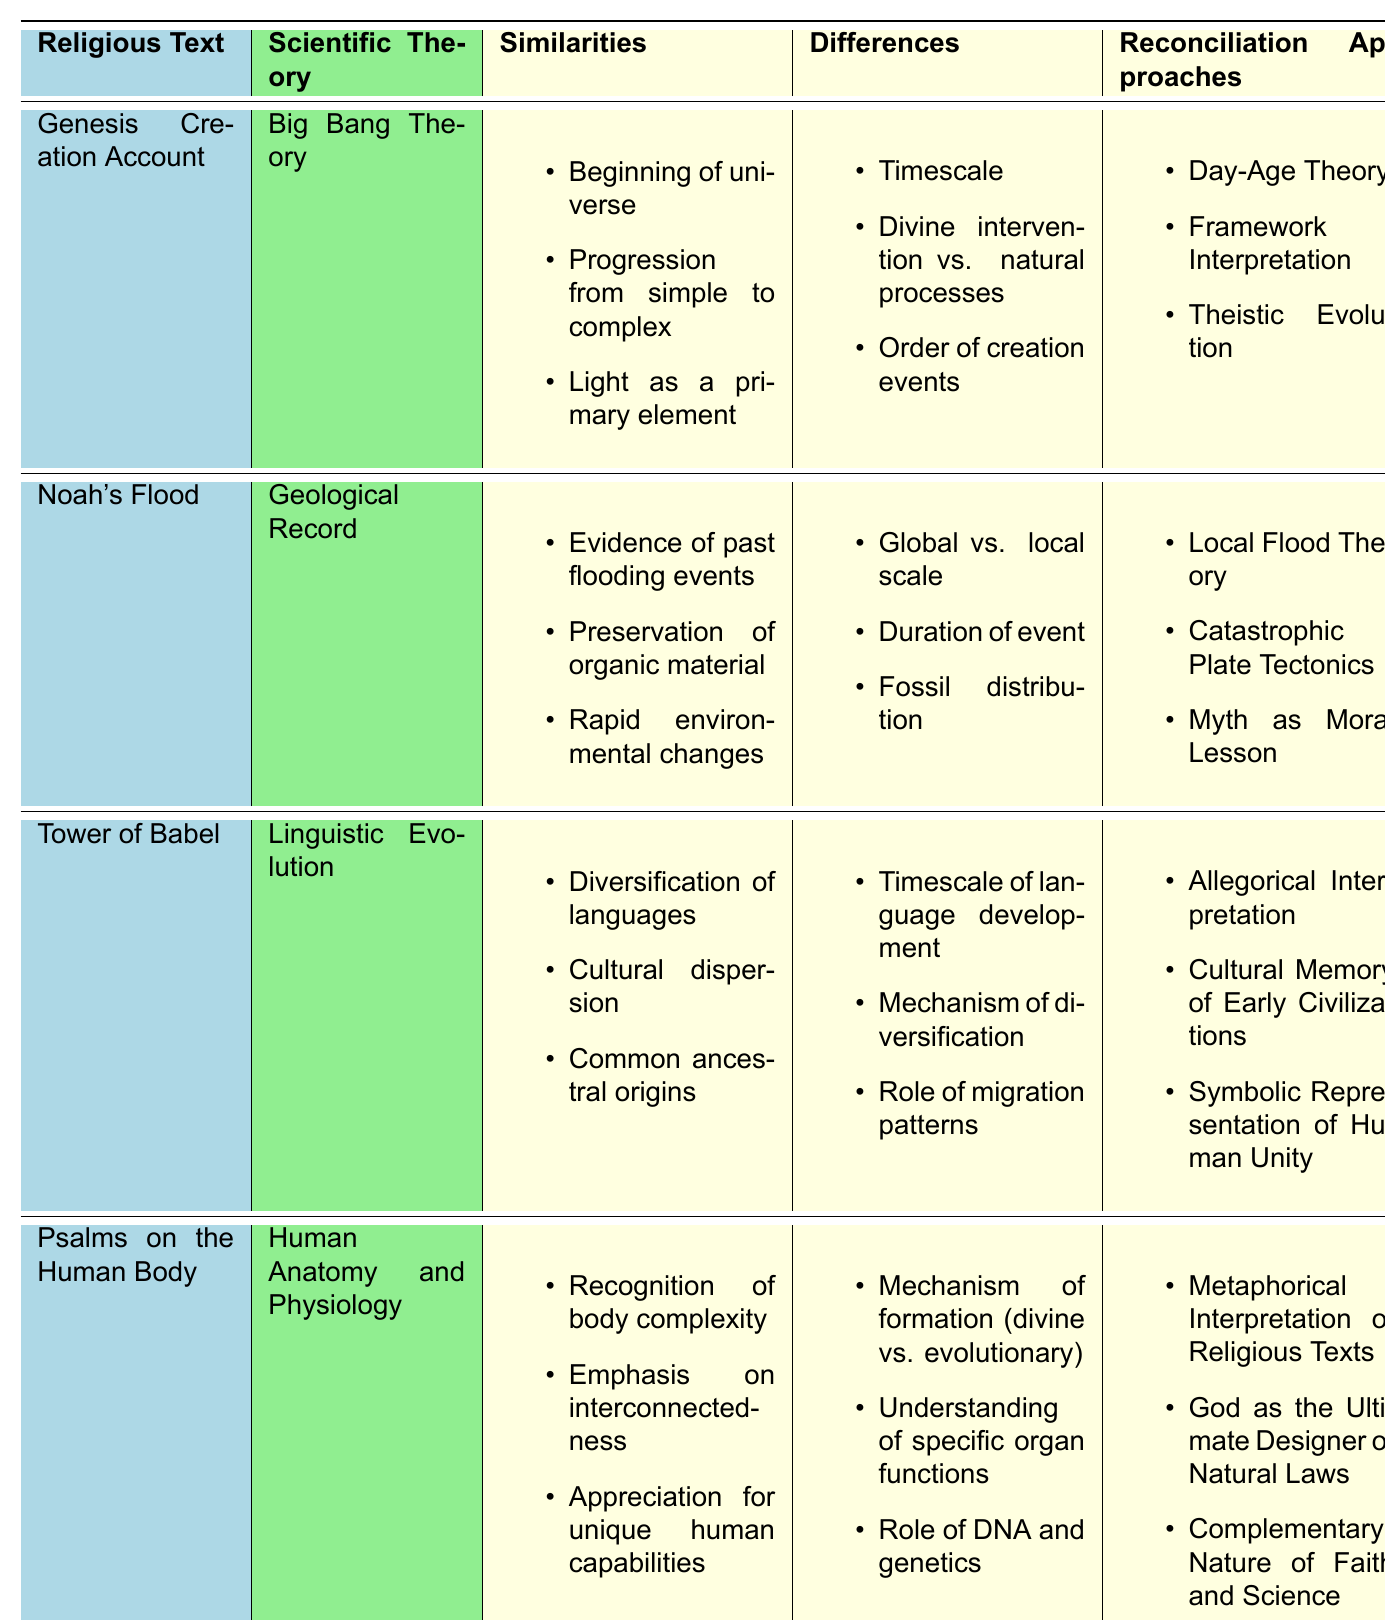What religious text corresponds with the Big Bang Theory? The first row of the table indicates that the Genesis Creation Account corresponds with the Big Bang Theory.
Answer: Genesis Creation Account What are the similarities between Noah's Flood and the Geological Record? The similarities listed in the second row include evidence of past flooding events, preservation of organic material, and rapid environmental changes.
Answer: Evidence of past flooding events, preservation of organic material, rapid environmental changes Which scientific theory relates to the Tower of Babel? The table specifies that Linguistic Evolution is the scientific theory that relates to the Tower of Babel.
Answer: Linguistic Evolution How many reconciliation approaches are provided for the Psalms on the Human Body? Looking at the table, the last row lists three reconciliation approaches: Metaphorical Interpretation of Religious Texts, God as the Ultimate Designer of Natural Laws, and Complementary Nature of Faith and Science.
Answer: Three Is the difference regarding the mechanism of formation between Psalms on the Human Body and Human Anatomy and Physiology primarily based on divine versus evolutionary explanations? The differences section for the last pair indicates that the mechanism of formation is indeed stated as divine versus evolutionary. Hence, the claim is true.
Answer: Yes Which reconciliation approach is mentioned for both Noah's Flood and Genesis Creation Account? Upon reviewing both sets of reconciliation approaches, it is evident that there is no overlap between the reconciliation approaches listed for Noah's Flood and Genesis Creation Account, leading to the conclusion that there is none stated.
Answer: None Can you list the differences between the Genesis Creation Account and the Big Bang Theory? Referring to the corresponding section in the table, the differences are: timescale, divine intervention vs. natural processes, and order of creation events.
Answer: Timescale, divine intervention vs. natural processes, order of creation events If we consider the differences between the Tower of Babel and Linguistic Evolution, which one reflects a longer timescale of language development? The second difference listed under the Tower of Babel indicates it has a longer timescale of language development than Linguistic Evolution.
Answer: Tower of Babel What is a reconciliation approach mentioned for the Tower of Babel that emphasizes human unity? The last reconciliation approach listed for the Tower of Babel mentions Symbolic Representation of Human Unity, which emphasizes unity.
Answer: Symbolic Representation of Human Unity Which religious text and scientific theory combination includes environmental changes as a similarity? By examining the table, the combination of Noah's Flood and Geological Record includes rapid environmental changes as a similarity.
Answer: Noah's Flood and Geological Record 